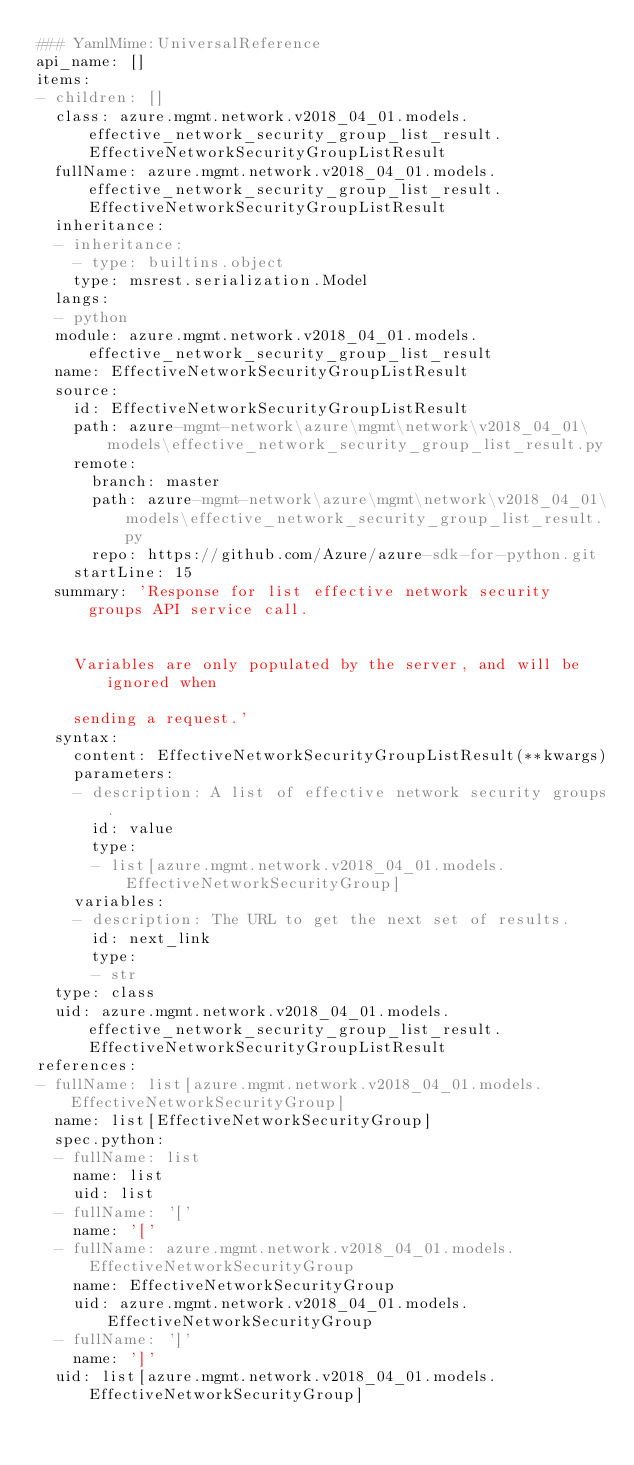Convert code to text. <code><loc_0><loc_0><loc_500><loc_500><_YAML_>### YamlMime:UniversalReference
api_name: []
items:
- children: []
  class: azure.mgmt.network.v2018_04_01.models.effective_network_security_group_list_result.EffectiveNetworkSecurityGroupListResult
  fullName: azure.mgmt.network.v2018_04_01.models.effective_network_security_group_list_result.EffectiveNetworkSecurityGroupListResult
  inheritance:
  - inheritance:
    - type: builtins.object
    type: msrest.serialization.Model
  langs:
  - python
  module: azure.mgmt.network.v2018_04_01.models.effective_network_security_group_list_result
  name: EffectiveNetworkSecurityGroupListResult
  source:
    id: EffectiveNetworkSecurityGroupListResult
    path: azure-mgmt-network\azure\mgmt\network\v2018_04_01\models\effective_network_security_group_list_result.py
    remote:
      branch: master
      path: azure-mgmt-network\azure\mgmt\network\v2018_04_01\models\effective_network_security_group_list_result.py
      repo: https://github.com/Azure/azure-sdk-for-python.git
    startLine: 15
  summary: 'Response for list effective network security groups API service call.


    Variables are only populated by the server, and will be ignored when

    sending a request.'
  syntax:
    content: EffectiveNetworkSecurityGroupListResult(**kwargs)
    parameters:
    - description: A list of effective network security groups.
      id: value
      type:
      - list[azure.mgmt.network.v2018_04_01.models.EffectiveNetworkSecurityGroup]
    variables:
    - description: The URL to get the next set of results.
      id: next_link
      type:
      - str
  type: class
  uid: azure.mgmt.network.v2018_04_01.models.effective_network_security_group_list_result.EffectiveNetworkSecurityGroupListResult
references:
- fullName: list[azure.mgmt.network.v2018_04_01.models.EffectiveNetworkSecurityGroup]
  name: list[EffectiveNetworkSecurityGroup]
  spec.python:
  - fullName: list
    name: list
    uid: list
  - fullName: '['
    name: '['
  - fullName: azure.mgmt.network.v2018_04_01.models.EffectiveNetworkSecurityGroup
    name: EffectiveNetworkSecurityGroup
    uid: azure.mgmt.network.v2018_04_01.models.EffectiveNetworkSecurityGroup
  - fullName: ']'
    name: ']'
  uid: list[azure.mgmt.network.v2018_04_01.models.EffectiveNetworkSecurityGroup]
</code> 